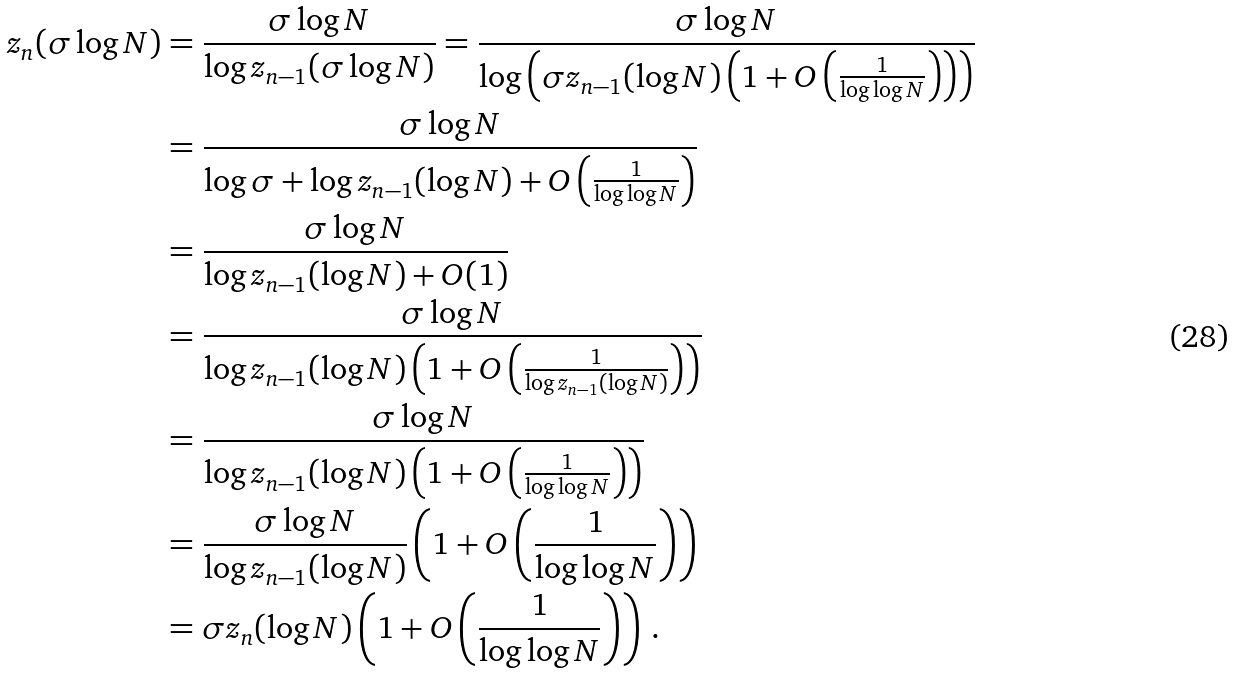<formula> <loc_0><loc_0><loc_500><loc_500>z _ { n } ( \sigma \log N ) & = \frac { \sigma \log N } { \log z _ { n - 1 } ( \sigma \log N ) } = \frac { \sigma \log N } { \log \left ( \sigma z _ { n - 1 } ( \log N ) \left ( 1 + O \left ( \frac { 1 } { \log \log N } \right ) \right ) \right ) } \\ & = \frac { \sigma \log N } { \log \sigma + \log z _ { n - 1 } ( \log N ) + O \left ( \frac { 1 } { \log \log N } \right ) } \\ & = \frac { \sigma \log N } { \log z _ { n - 1 } ( \log N ) + O ( 1 ) } \\ & = \frac { \sigma \log N } { \log z _ { n - 1 } ( \log N ) \left ( 1 + O \left ( \frac { 1 } { \log z _ { n - 1 } ( \log N ) } \right ) \right ) } \\ & = \frac { \sigma \log N } { \log z _ { n - 1 } ( \log N ) \left ( 1 + O \left ( \frac { 1 } { \log \log N } \right ) \right ) } \\ & = \frac { \sigma \log N } { \log z _ { n - 1 } ( \log N ) } \left ( 1 + O \left ( \frac { 1 } { \log \log N } \right ) \right ) \\ & = \sigma z _ { n } ( \log N ) \left ( 1 + O \left ( \frac { 1 } { \log \log N } \right ) \right ) \, .</formula> 